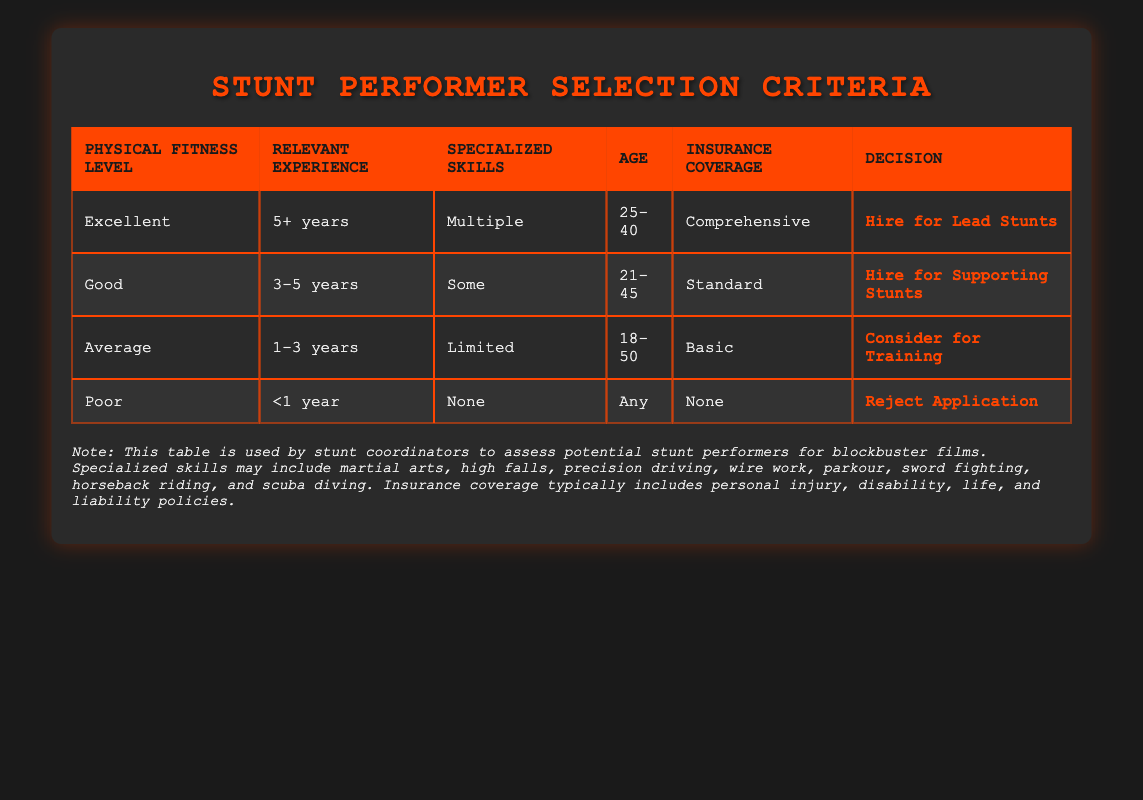What is the physical fitness level required to hire a performer for lead stunts? According to the table, a performer must have an "Excellent" physical fitness level to be hired for lead stunts.
Answer: Excellent How many years of relevant experience are needed for a performer to be hired for supporting stunts? The table indicates that a performer requires "3-5 years" of relevant experience to be hired for supporting stunts.
Answer: 3-5 years Is it possible to hire someone with poor physical fitness for any stunts? The table shows that if a performer has a "Poor" physical fitness level, they will be rejected regardless of their age or experience.
Answer: No What age range applies to performers hired for lead stunts? The table lists the age range for hiring lead stunt performers as "25-40."
Answer: 25-40 If a performer has limited specialized skills, what action is taken according to the table? The table states that a performer with "Limited" specialized skills is suggested to be considered for training.
Answer: Consider for Training How many unique age categories appear in the table? The age categories listed are: "25-40," "21-45," "18-50," and "Any." These categories are not unique since they overlap, but counting the distinct ranges results in three categories.
Answer: 3 What happens to someone who has comprehensive insurance but only 1 year of relevant experience? According to the rules, having only "1-3 years" of experience with comprehensive insurance would lead to the decision of considering them for training.
Answer: Consider for Training What is the maximum age for someone eligible to be considered for training? The relevant experience for training allows ages from 18 to 50. Therefore, the maximum age eligible to be considered for training is 50.
Answer: 50 If a performer meets all the conditions but has "None" as their specialized skills, what is the decision? The table rules indicate that a performer with "None" specialized skills will be rejected, regardless of their other qualifications.
Answer: Reject Application 